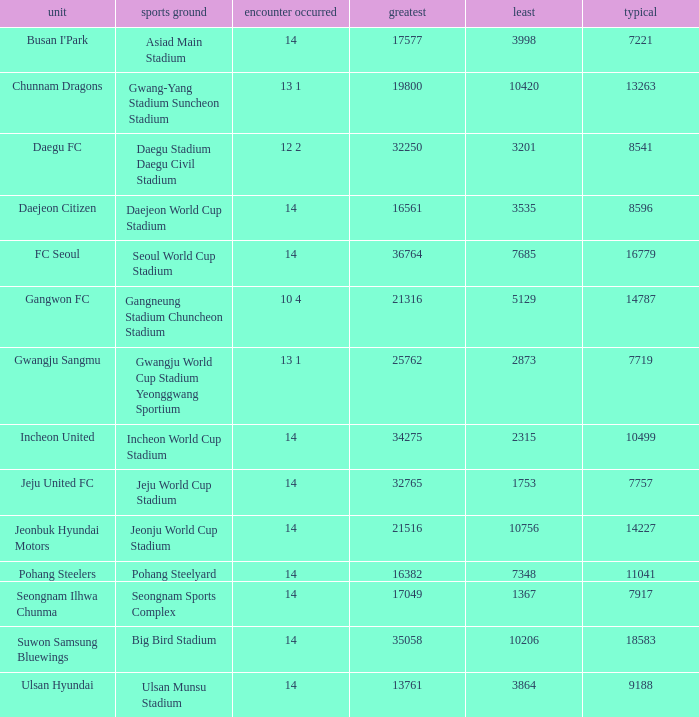How many match played have the highest as 32250? 12 2. 